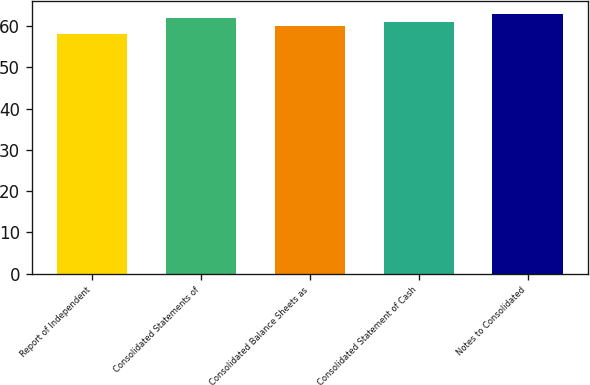Convert chart to OTSL. <chart><loc_0><loc_0><loc_500><loc_500><bar_chart><fcel>Report of Independent<fcel>Consolidated Statements of<fcel>Consolidated Balance Sheets as<fcel>Consolidated Statement of Cash<fcel>Notes to Consolidated<nl><fcel>58<fcel>62<fcel>60<fcel>61<fcel>63<nl></chart> 